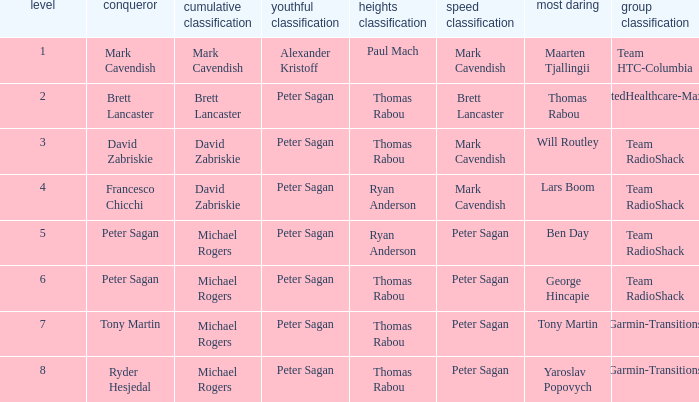Who won the mountains classification when Maarten Tjallingii won most corageous? Paul Mach. 